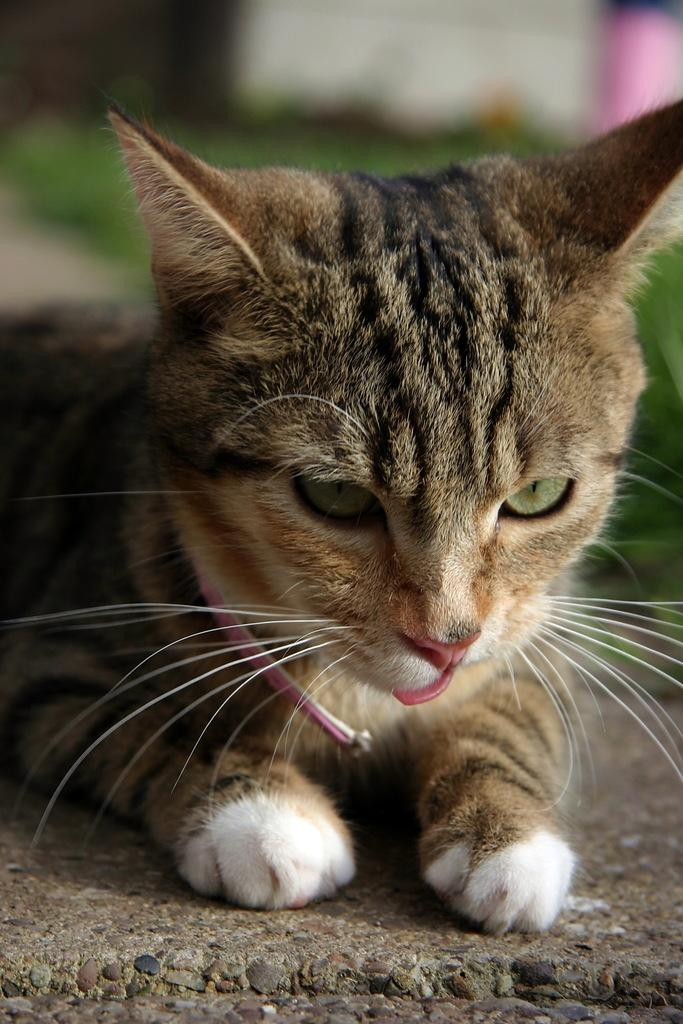What animal is in the picture? There is a cat in the picture. What colors can be seen on the cat? The cat has black, brown, and white colors. What type of surface is visible on the ground in the picture? There is grass on the ground in the picture. How many balloons are being held by the wren in the picture? There is no wren or balloons present in the image; it features a cat and grass. 